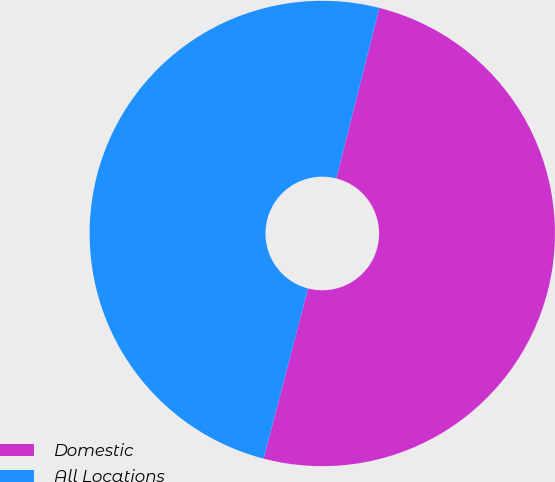Convert chart. <chart><loc_0><loc_0><loc_500><loc_500><pie_chart><fcel>Domestic<fcel>All Locations<nl><fcel>50.11%<fcel>49.89%<nl></chart> 